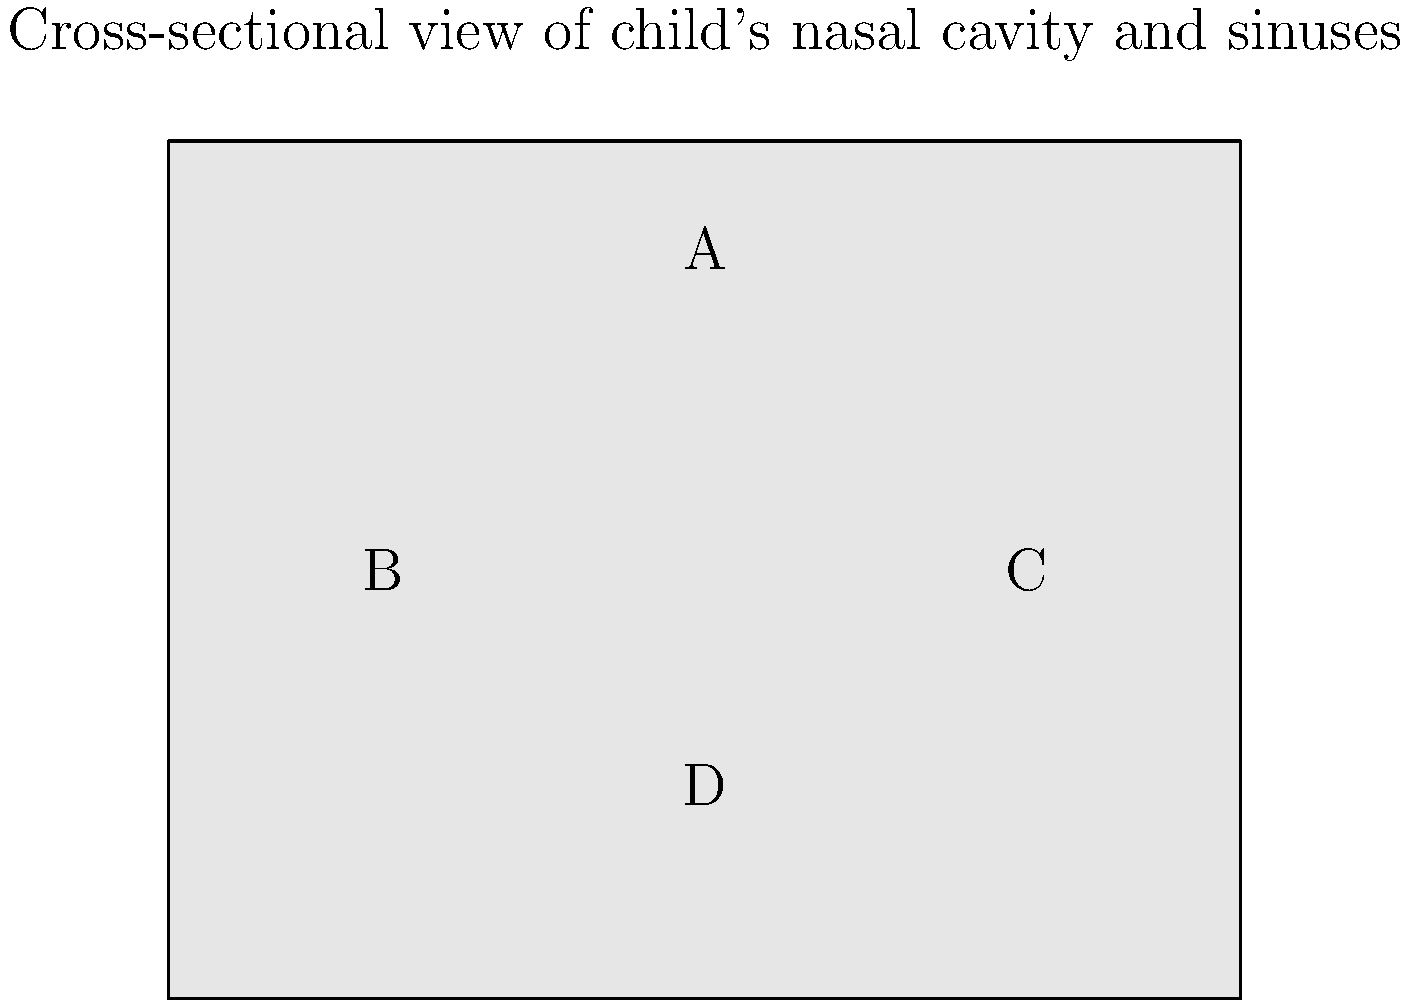In the cross-sectional image of a child's nasal cavity and sinuses shown above, identify the anatomical structure labeled 'B'. To identify the anatomical structure labeled 'B' in the cross-sectional image of a child's nasal cavity and sinuses, we need to consider the following steps:

1. Orientation: The image shows a frontal cross-section of the nasal cavity and sinuses, with the top of the image representing the superior aspect and the bottom representing the inferior aspect.

2. Anatomical knowledge: In a typical cross-section of this area, we expect to see the following structures:
   a. Frontal sinuses (superior)
   b. Ethmoid sinuses (superior-lateral)
   c. Nasal cavity (central)
   d. Maxillary sinuses (inferior-lateral)

3. Location analysis: Structure 'B' is located in the lateral aspect of the image, at approximately mid-height.

4. Size and shape: The structure appears to be a relatively large, air-filled space.

5. Comparison with other structures: 'A' likely represents the frontal sinus or ethmoid sinus, 'C' is symmetrical to 'B', and 'D' is likely the nasal cavity.

6. Age consideration: Given that this is a pediatric case, we need to consider the developmental stage of the sinuses. The maxillary sinuses are one of the first to develop and are usually well-formed in children.

Based on these considerations, the anatomical structure labeled 'B' is most likely the maxillary sinus. This air-filled cavity is located in the appropriate position for a maxillary sinus in a cross-sectional view of a child's nasal area.
Answer: Maxillary sinus 